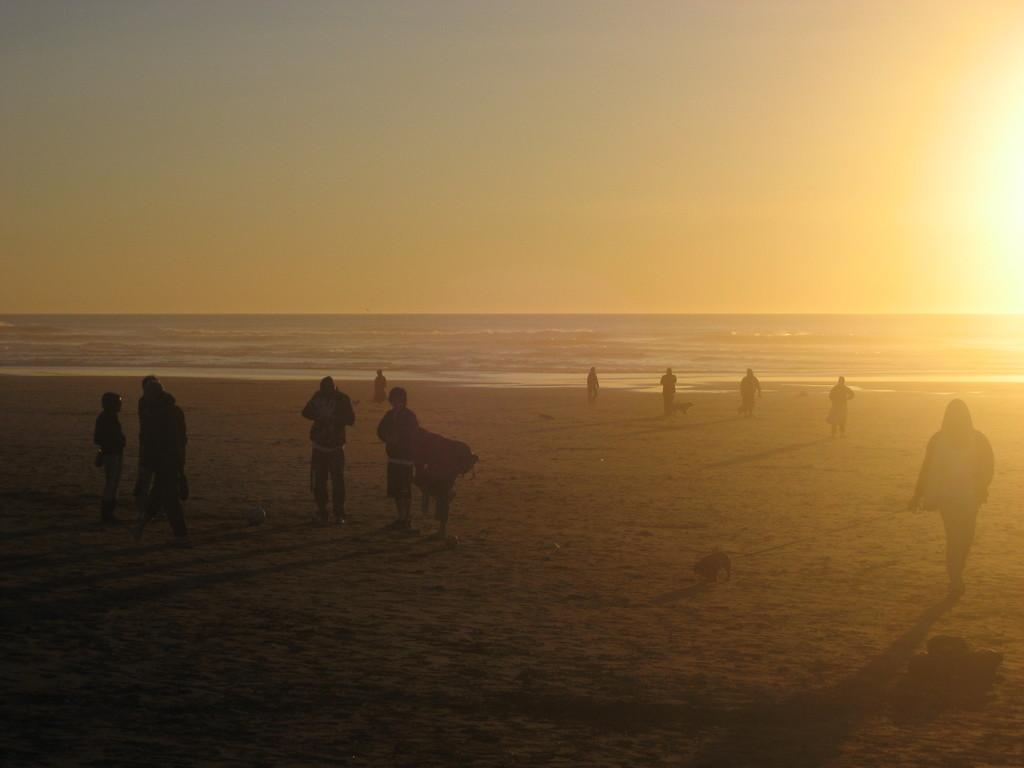What are the people in the image doing? There are persons standing and walking in the image. What can be seen in the background of the image? There is an ocean in the background of the image. What type of railway can be seen in the image? There is no railway present in the image; it features persons standing and walking near an ocean. 